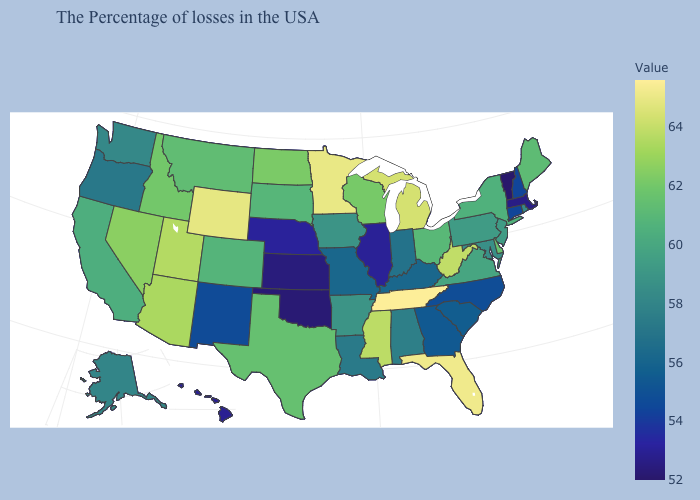Does Louisiana have a lower value than Oklahoma?
Concise answer only. No. Among the states that border New Jersey , does Pennsylvania have the highest value?
Write a very short answer. No. Which states have the lowest value in the USA?
Quick response, please. Vermont. Among the states that border Indiana , does Michigan have the lowest value?
Quick response, please. No. Does Tennessee have the highest value in the USA?
Concise answer only. Yes. Does Wisconsin have a higher value than New Hampshire?
Write a very short answer. Yes. Does Montana have the highest value in the USA?
Write a very short answer. No. 